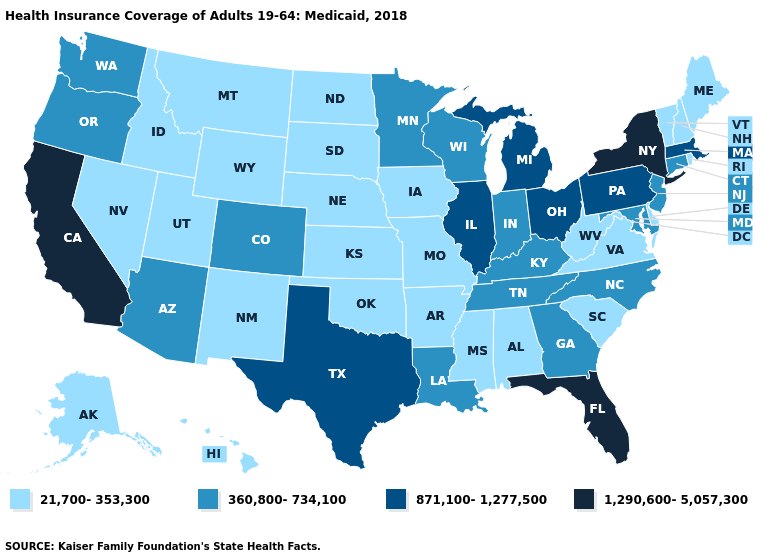Which states have the lowest value in the USA?
Quick response, please. Alabama, Alaska, Arkansas, Delaware, Hawaii, Idaho, Iowa, Kansas, Maine, Mississippi, Missouri, Montana, Nebraska, Nevada, New Hampshire, New Mexico, North Dakota, Oklahoma, Rhode Island, South Carolina, South Dakota, Utah, Vermont, Virginia, West Virginia, Wyoming. Does Tennessee have the lowest value in the USA?
Give a very brief answer. No. Is the legend a continuous bar?
Keep it brief. No. Among the states that border Vermont , which have the lowest value?
Short answer required. New Hampshire. What is the value of South Dakota?
Short answer required. 21,700-353,300. Name the states that have a value in the range 360,800-734,100?
Be succinct. Arizona, Colorado, Connecticut, Georgia, Indiana, Kentucky, Louisiana, Maryland, Minnesota, New Jersey, North Carolina, Oregon, Tennessee, Washington, Wisconsin. How many symbols are there in the legend?
Keep it brief. 4. What is the value of Wisconsin?
Keep it brief. 360,800-734,100. Does Arkansas have the highest value in the South?
Answer briefly. No. Among the states that border West Virginia , which have the highest value?
Give a very brief answer. Ohio, Pennsylvania. What is the lowest value in states that border South Dakota?
Write a very short answer. 21,700-353,300. Among the states that border Iowa , which have the lowest value?
Quick response, please. Missouri, Nebraska, South Dakota. Does Michigan have the lowest value in the USA?
Keep it brief. No. How many symbols are there in the legend?
Be succinct. 4. What is the value of Michigan?
Be succinct. 871,100-1,277,500. 